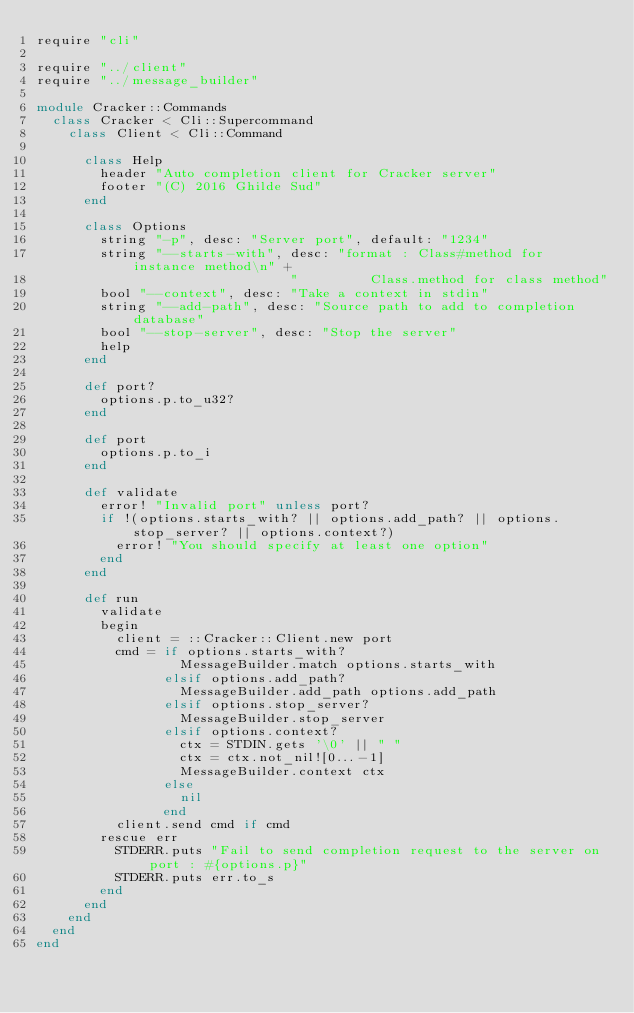<code> <loc_0><loc_0><loc_500><loc_500><_Crystal_>require "cli"

require "../client"
require "../message_builder"

module Cracker::Commands
  class Cracker < Cli::Supercommand
    class Client < Cli::Command

      class Help
        header "Auto completion client for Cracker server"
        footer "(C) 2016 Ghilde Sud"
      end

      class Options
        string "-p", desc: "Server port", default: "1234"
        string "--starts-with", desc: "format : Class#method for instance method\n" +
                                "         Class.method for class method"
        bool "--context", desc: "Take a context in stdin"
        string "--add-path", desc: "Source path to add to completion database"
        bool "--stop-server", desc: "Stop the server"
        help
      end

      def port?
        options.p.to_u32?
      end

      def port
        options.p.to_i
      end

      def validate
        error! "Invalid port" unless port?
        if !(options.starts_with? || options.add_path? || options.stop_server? || options.context?)
          error! "You should specify at least one option"
        end
      end

      def run
        validate
        begin
          client = ::Cracker::Client.new port
          cmd = if options.starts_with?
                  MessageBuilder.match options.starts_with
                elsif options.add_path?
                  MessageBuilder.add_path options.add_path
                elsif options.stop_server?
                  MessageBuilder.stop_server
                elsif options.context?
                  ctx = STDIN.gets '\0' || " "
                  ctx = ctx.not_nil![0...-1]
                  MessageBuilder.context ctx
                else
                  nil
                end
          client.send cmd if cmd
        rescue err
          STDERR.puts "Fail to send completion request to the server on port : #{options.p}"
          STDERR.puts err.to_s
        end
      end
    end
  end
end
</code> 